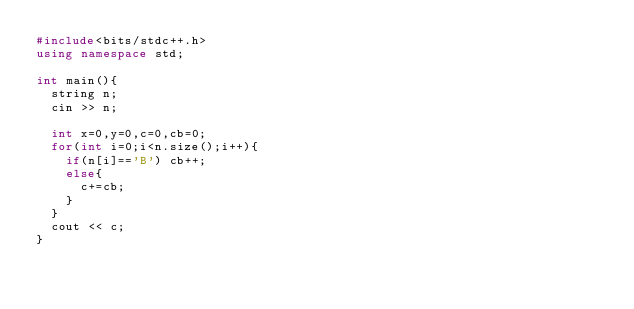Convert code to text. <code><loc_0><loc_0><loc_500><loc_500><_C++_>#include<bits/stdc++.h>
using namespace std;

int main(){
  string n;
  cin >> n;
  
  int x=0,y=0,c=0,cb=0;
  for(int i=0;i<n.size();i++){
    if(n[i]=='B') cb++;
    else{
      c+=cb;
    }
  }
  cout << c;
}</code> 